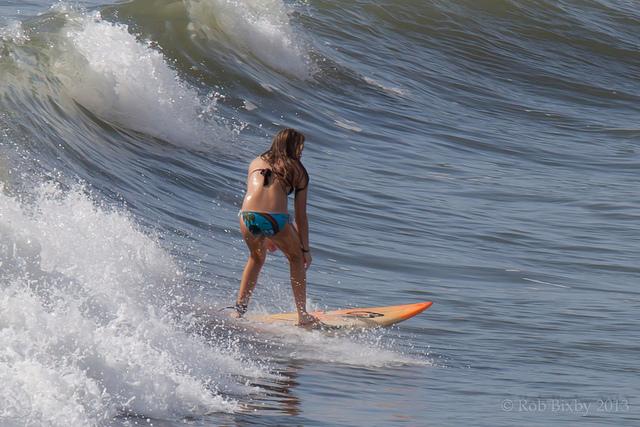Who rides the wave?
Be succinct. Woman. IS that a women?
Answer briefly. Yes. Does the woman have long hair?
Answer briefly. Yes. 